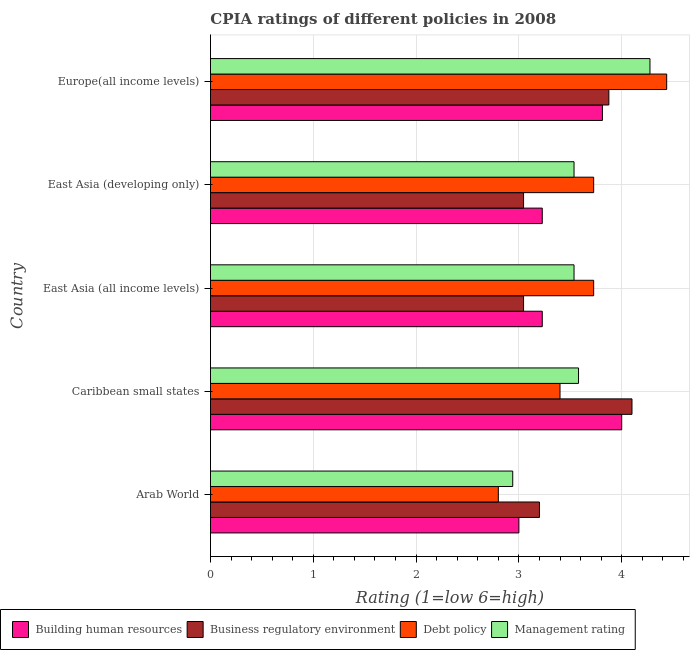Are the number of bars on each tick of the Y-axis equal?
Make the answer very short. Yes. How many bars are there on the 2nd tick from the bottom?
Provide a short and direct response. 4. What is the label of the 3rd group of bars from the top?
Make the answer very short. East Asia (all income levels). What is the cpia rating of business regulatory environment in Europe(all income levels)?
Provide a succinct answer. 3.88. In which country was the cpia rating of debt policy maximum?
Ensure brevity in your answer.  Europe(all income levels). In which country was the cpia rating of management minimum?
Keep it short and to the point. Arab World. What is the total cpia rating of business regulatory environment in the graph?
Your answer should be compact. 17.27. What is the difference between the cpia rating of business regulatory environment in East Asia (developing only) and that in Europe(all income levels)?
Offer a terse response. -0.83. What is the difference between the cpia rating of building human resources in Europe(all income levels) and the cpia rating of management in East Asia (all income levels)?
Make the answer very short. 0.28. What is the average cpia rating of debt policy per country?
Provide a succinct answer. 3.62. What is the ratio of the cpia rating of business regulatory environment in East Asia (developing only) to that in Europe(all income levels)?
Offer a terse response. 0.79. What is the difference between the highest and the second highest cpia rating of building human resources?
Ensure brevity in your answer.  0.19. What is the difference between the highest and the lowest cpia rating of debt policy?
Your response must be concise. 1.64. Is the sum of the cpia rating of management in Caribbean small states and Europe(all income levels) greater than the maximum cpia rating of debt policy across all countries?
Offer a very short reply. Yes. What does the 4th bar from the top in East Asia (all income levels) represents?
Your response must be concise. Building human resources. What does the 1st bar from the bottom in Caribbean small states represents?
Your answer should be very brief. Building human resources. What is the difference between two consecutive major ticks on the X-axis?
Provide a short and direct response. 1. Are the values on the major ticks of X-axis written in scientific E-notation?
Ensure brevity in your answer.  No. Does the graph contain any zero values?
Make the answer very short. No. How many legend labels are there?
Ensure brevity in your answer.  4. How are the legend labels stacked?
Provide a short and direct response. Horizontal. What is the title of the graph?
Provide a short and direct response. CPIA ratings of different policies in 2008. Does "Japan" appear as one of the legend labels in the graph?
Provide a succinct answer. No. What is the label or title of the X-axis?
Offer a very short reply. Rating (1=low 6=high). What is the Rating (1=low 6=high) of Building human resources in Arab World?
Your response must be concise. 3. What is the Rating (1=low 6=high) in Business regulatory environment in Arab World?
Offer a very short reply. 3.2. What is the Rating (1=low 6=high) in Management rating in Arab World?
Your answer should be compact. 2.94. What is the Rating (1=low 6=high) of Business regulatory environment in Caribbean small states?
Make the answer very short. 4.1. What is the Rating (1=low 6=high) of Management rating in Caribbean small states?
Give a very brief answer. 3.58. What is the Rating (1=low 6=high) in Building human resources in East Asia (all income levels)?
Your response must be concise. 3.23. What is the Rating (1=low 6=high) in Business regulatory environment in East Asia (all income levels)?
Offer a very short reply. 3.05. What is the Rating (1=low 6=high) of Debt policy in East Asia (all income levels)?
Ensure brevity in your answer.  3.73. What is the Rating (1=low 6=high) of Management rating in East Asia (all income levels)?
Your answer should be very brief. 3.54. What is the Rating (1=low 6=high) of Building human resources in East Asia (developing only)?
Your answer should be very brief. 3.23. What is the Rating (1=low 6=high) of Business regulatory environment in East Asia (developing only)?
Give a very brief answer. 3.05. What is the Rating (1=low 6=high) in Debt policy in East Asia (developing only)?
Ensure brevity in your answer.  3.73. What is the Rating (1=low 6=high) in Management rating in East Asia (developing only)?
Your response must be concise. 3.54. What is the Rating (1=low 6=high) of Building human resources in Europe(all income levels)?
Provide a succinct answer. 3.81. What is the Rating (1=low 6=high) of Business regulatory environment in Europe(all income levels)?
Offer a very short reply. 3.88. What is the Rating (1=low 6=high) in Debt policy in Europe(all income levels)?
Provide a short and direct response. 4.44. What is the Rating (1=low 6=high) in Management rating in Europe(all income levels)?
Ensure brevity in your answer.  4.28. Across all countries, what is the maximum Rating (1=low 6=high) in Debt policy?
Make the answer very short. 4.44. Across all countries, what is the maximum Rating (1=low 6=high) of Management rating?
Offer a terse response. 4.28. Across all countries, what is the minimum Rating (1=low 6=high) in Business regulatory environment?
Ensure brevity in your answer.  3.05. Across all countries, what is the minimum Rating (1=low 6=high) in Management rating?
Offer a terse response. 2.94. What is the total Rating (1=low 6=high) of Building human resources in the graph?
Your response must be concise. 17.27. What is the total Rating (1=low 6=high) of Business regulatory environment in the graph?
Your answer should be very brief. 17.27. What is the total Rating (1=low 6=high) in Debt policy in the graph?
Provide a short and direct response. 18.09. What is the total Rating (1=low 6=high) of Management rating in the graph?
Provide a short and direct response. 17.87. What is the difference between the Rating (1=low 6=high) in Business regulatory environment in Arab World and that in Caribbean small states?
Your answer should be very brief. -0.9. What is the difference between the Rating (1=low 6=high) in Debt policy in Arab World and that in Caribbean small states?
Your answer should be very brief. -0.6. What is the difference between the Rating (1=low 6=high) in Management rating in Arab World and that in Caribbean small states?
Your response must be concise. -0.64. What is the difference between the Rating (1=low 6=high) of Building human resources in Arab World and that in East Asia (all income levels)?
Your response must be concise. -0.23. What is the difference between the Rating (1=low 6=high) in Business regulatory environment in Arab World and that in East Asia (all income levels)?
Offer a terse response. 0.15. What is the difference between the Rating (1=low 6=high) of Debt policy in Arab World and that in East Asia (all income levels)?
Give a very brief answer. -0.93. What is the difference between the Rating (1=low 6=high) in Management rating in Arab World and that in East Asia (all income levels)?
Offer a very short reply. -0.6. What is the difference between the Rating (1=low 6=high) in Building human resources in Arab World and that in East Asia (developing only)?
Your response must be concise. -0.23. What is the difference between the Rating (1=low 6=high) of Business regulatory environment in Arab World and that in East Asia (developing only)?
Your answer should be very brief. 0.15. What is the difference between the Rating (1=low 6=high) in Debt policy in Arab World and that in East Asia (developing only)?
Offer a terse response. -0.93. What is the difference between the Rating (1=low 6=high) in Management rating in Arab World and that in East Asia (developing only)?
Offer a very short reply. -0.6. What is the difference between the Rating (1=low 6=high) in Building human resources in Arab World and that in Europe(all income levels)?
Keep it short and to the point. -0.81. What is the difference between the Rating (1=low 6=high) of Business regulatory environment in Arab World and that in Europe(all income levels)?
Provide a short and direct response. -0.68. What is the difference between the Rating (1=low 6=high) of Debt policy in Arab World and that in Europe(all income levels)?
Offer a very short reply. -1.64. What is the difference between the Rating (1=low 6=high) in Management rating in Arab World and that in Europe(all income levels)?
Provide a succinct answer. -1.33. What is the difference between the Rating (1=low 6=high) in Building human resources in Caribbean small states and that in East Asia (all income levels)?
Provide a succinct answer. 0.77. What is the difference between the Rating (1=low 6=high) in Business regulatory environment in Caribbean small states and that in East Asia (all income levels)?
Provide a succinct answer. 1.05. What is the difference between the Rating (1=low 6=high) of Debt policy in Caribbean small states and that in East Asia (all income levels)?
Keep it short and to the point. -0.33. What is the difference between the Rating (1=low 6=high) of Management rating in Caribbean small states and that in East Asia (all income levels)?
Your answer should be compact. 0.04. What is the difference between the Rating (1=low 6=high) in Building human resources in Caribbean small states and that in East Asia (developing only)?
Your answer should be very brief. 0.77. What is the difference between the Rating (1=low 6=high) in Business regulatory environment in Caribbean small states and that in East Asia (developing only)?
Offer a terse response. 1.05. What is the difference between the Rating (1=low 6=high) of Debt policy in Caribbean small states and that in East Asia (developing only)?
Offer a terse response. -0.33. What is the difference between the Rating (1=low 6=high) in Management rating in Caribbean small states and that in East Asia (developing only)?
Your answer should be compact. 0.04. What is the difference between the Rating (1=low 6=high) in Building human resources in Caribbean small states and that in Europe(all income levels)?
Offer a very short reply. 0.19. What is the difference between the Rating (1=low 6=high) in Business regulatory environment in Caribbean small states and that in Europe(all income levels)?
Provide a short and direct response. 0.23. What is the difference between the Rating (1=low 6=high) in Debt policy in Caribbean small states and that in Europe(all income levels)?
Provide a succinct answer. -1.04. What is the difference between the Rating (1=low 6=high) of Management rating in Caribbean small states and that in Europe(all income levels)?
Ensure brevity in your answer.  -0.69. What is the difference between the Rating (1=low 6=high) in Building human resources in East Asia (all income levels) and that in East Asia (developing only)?
Provide a short and direct response. 0. What is the difference between the Rating (1=low 6=high) of Building human resources in East Asia (all income levels) and that in Europe(all income levels)?
Keep it short and to the point. -0.59. What is the difference between the Rating (1=low 6=high) of Business regulatory environment in East Asia (all income levels) and that in Europe(all income levels)?
Keep it short and to the point. -0.83. What is the difference between the Rating (1=low 6=high) in Debt policy in East Asia (all income levels) and that in Europe(all income levels)?
Ensure brevity in your answer.  -0.71. What is the difference between the Rating (1=low 6=high) in Management rating in East Asia (all income levels) and that in Europe(all income levels)?
Your answer should be compact. -0.74. What is the difference between the Rating (1=low 6=high) of Building human resources in East Asia (developing only) and that in Europe(all income levels)?
Offer a terse response. -0.59. What is the difference between the Rating (1=low 6=high) in Business regulatory environment in East Asia (developing only) and that in Europe(all income levels)?
Your answer should be compact. -0.83. What is the difference between the Rating (1=low 6=high) in Debt policy in East Asia (developing only) and that in Europe(all income levels)?
Provide a short and direct response. -0.71. What is the difference between the Rating (1=low 6=high) of Management rating in East Asia (developing only) and that in Europe(all income levels)?
Offer a terse response. -0.74. What is the difference between the Rating (1=low 6=high) of Building human resources in Arab World and the Rating (1=low 6=high) of Business regulatory environment in Caribbean small states?
Offer a terse response. -1.1. What is the difference between the Rating (1=low 6=high) of Building human resources in Arab World and the Rating (1=low 6=high) of Management rating in Caribbean small states?
Ensure brevity in your answer.  -0.58. What is the difference between the Rating (1=low 6=high) of Business regulatory environment in Arab World and the Rating (1=low 6=high) of Management rating in Caribbean small states?
Offer a very short reply. -0.38. What is the difference between the Rating (1=low 6=high) of Debt policy in Arab World and the Rating (1=low 6=high) of Management rating in Caribbean small states?
Provide a succinct answer. -0.78. What is the difference between the Rating (1=low 6=high) in Building human resources in Arab World and the Rating (1=low 6=high) in Business regulatory environment in East Asia (all income levels)?
Your response must be concise. -0.05. What is the difference between the Rating (1=low 6=high) in Building human resources in Arab World and the Rating (1=low 6=high) in Debt policy in East Asia (all income levels)?
Your answer should be very brief. -0.73. What is the difference between the Rating (1=low 6=high) of Building human resources in Arab World and the Rating (1=low 6=high) of Management rating in East Asia (all income levels)?
Offer a terse response. -0.54. What is the difference between the Rating (1=low 6=high) of Business regulatory environment in Arab World and the Rating (1=low 6=high) of Debt policy in East Asia (all income levels)?
Your response must be concise. -0.53. What is the difference between the Rating (1=low 6=high) of Business regulatory environment in Arab World and the Rating (1=low 6=high) of Management rating in East Asia (all income levels)?
Provide a short and direct response. -0.34. What is the difference between the Rating (1=low 6=high) in Debt policy in Arab World and the Rating (1=low 6=high) in Management rating in East Asia (all income levels)?
Your answer should be very brief. -0.74. What is the difference between the Rating (1=low 6=high) in Building human resources in Arab World and the Rating (1=low 6=high) in Business regulatory environment in East Asia (developing only)?
Make the answer very short. -0.05. What is the difference between the Rating (1=low 6=high) in Building human resources in Arab World and the Rating (1=low 6=high) in Debt policy in East Asia (developing only)?
Your answer should be very brief. -0.73. What is the difference between the Rating (1=low 6=high) of Building human resources in Arab World and the Rating (1=low 6=high) of Management rating in East Asia (developing only)?
Offer a very short reply. -0.54. What is the difference between the Rating (1=low 6=high) of Business regulatory environment in Arab World and the Rating (1=low 6=high) of Debt policy in East Asia (developing only)?
Provide a succinct answer. -0.53. What is the difference between the Rating (1=low 6=high) in Business regulatory environment in Arab World and the Rating (1=low 6=high) in Management rating in East Asia (developing only)?
Keep it short and to the point. -0.34. What is the difference between the Rating (1=low 6=high) in Debt policy in Arab World and the Rating (1=low 6=high) in Management rating in East Asia (developing only)?
Offer a very short reply. -0.74. What is the difference between the Rating (1=low 6=high) in Building human resources in Arab World and the Rating (1=low 6=high) in Business regulatory environment in Europe(all income levels)?
Make the answer very short. -0.88. What is the difference between the Rating (1=low 6=high) in Building human resources in Arab World and the Rating (1=low 6=high) in Debt policy in Europe(all income levels)?
Offer a very short reply. -1.44. What is the difference between the Rating (1=low 6=high) in Building human resources in Arab World and the Rating (1=low 6=high) in Management rating in Europe(all income levels)?
Offer a terse response. -1.27. What is the difference between the Rating (1=low 6=high) of Business regulatory environment in Arab World and the Rating (1=low 6=high) of Debt policy in Europe(all income levels)?
Your answer should be very brief. -1.24. What is the difference between the Rating (1=low 6=high) in Business regulatory environment in Arab World and the Rating (1=low 6=high) in Management rating in Europe(all income levels)?
Your answer should be compact. -1.07. What is the difference between the Rating (1=low 6=high) in Debt policy in Arab World and the Rating (1=low 6=high) in Management rating in Europe(all income levels)?
Your answer should be very brief. -1.48. What is the difference between the Rating (1=low 6=high) of Building human resources in Caribbean small states and the Rating (1=low 6=high) of Business regulatory environment in East Asia (all income levels)?
Offer a terse response. 0.95. What is the difference between the Rating (1=low 6=high) in Building human resources in Caribbean small states and the Rating (1=low 6=high) in Debt policy in East Asia (all income levels)?
Make the answer very short. 0.27. What is the difference between the Rating (1=low 6=high) of Building human resources in Caribbean small states and the Rating (1=low 6=high) of Management rating in East Asia (all income levels)?
Your response must be concise. 0.46. What is the difference between the Rating (1=low 6=high) in Business regulatory environment in Caribbean small states and the Rating (1=low 6=high) in Debt policy in East Asia (all income levels)?
Provide a succinct answer. 0.37. What is the difference between the Rating (1=low 6=high) in Business regulatory environment in Caribbean small states and the Rating (1=low 6=high) in Management rating in East Asia (all income levels)?
Make the answer very short. 0.56. What is the difference between the Rating (1=low 6=high) of Debt policy in Caribbean small states and the Rating (1=low 6=high) of Management rating in East Asia (all income levels)?
Offer a terse response. -0.14. What is the difference between the Rating (1=low 6=high) in Building human resources in Caribbean small states and the Rating (1=low 6=high) in Business regulatory environment in East Asia (developing only)?
Your response must be concise. 0.95. What is the difference between the Rating (1=low 6=high) in Building human resources in Caribbean small states and the Rating (1=low 6=high) in Debt policy in East Asia (developing only)?
Your response must be concise. 0.27. What is the difference between the Rating (1=low 6=high) of Building human resources in Caribbean small states and the Rating (1=low 6=high) of Management rating in East Asia (developing only)?
Keep it short and to the point. 0.46. What is the difference between the Rating (1=low 6=high) of Business regulatory environment in Caribbean small states and the Rating (1=low 6=high) of Debt policy in East Asia (developing only)?
Make the answer very short. 0.37. What is the difference between the Rating (1=low 6=high) of Business regulatory environment in Caribbean small states and the Rating (1=low 6=high) of Management rating in East Asia (developing only)?
Provide a succinct answer. 0.56. What is the difference between the Rating (1=low 6=high) of Debt policy in Caribbean small states and the Rating (1=low 6=high) of Management rating in East Asia (developing only)?
Your answer should be compact. -0.14. What is the difference between the Rating (1=low 6=high) of Building human resources in Caribbean small states and the Rating (1=low 6=high) of Debt policy in Europe(all income levels)?
Keep it short and to the point. -0.44. What is the difference between the Rating (1=low 6=high) in Building human resources in Caribbean small states and the Rating (1=low 6=high) in Management rating in Europe(all income levels)?
Make the answer very short. -0.28. What is the difference between the Rating (1=low 6=high) of Business regulatory environment in Caribbean small states and the Rating (1=low 6=high) of Debt policy in Europe(all income levels)?
Offer a terse response. -0.34. What is the difference between the Rating (1=low 6=high) of Business regulatory environment in Caribbean small states and the Rating (1=low 6=high) of Management rating in Europe(all income levels)?
Offer a very short reply. -0.17. What is the difference between the Rating (1=low 6=high) in Debt policy in Caribbean small states and the Rating (1=low 6=high) in Management rating in Europe(all income levels)?
Offer a terse response. -0.88. What is the difference between the Rating (1=low 6=high) of Building human resources in East Asia (all income levels) and the Rating (1=low 6=high) of Business regulatory environment in East Asia (developing only)?
Offer a very short reply. 0.18. What is the difference between the Rating (1=low 6=high) in Building human resources in East Asia (all income levels) and the Rating (1=low 6=high) in Debt policy in East Asia (developing only)?
Provide a succinct answer. -0.5. What is the difference between the Rating (1=low 6=high) of Building human resources in East Asia (all income levels) and the Rating (1=low 6=high) of Management rating in East Asia (developing only)?
Give a very brief answer. -0.31. What is the difference between the Rating (1=low 6=high) of Business regulatory environment in East Asia (all income levels) and the Rating (1=low 6=high) of Debt policy in East Asia (developing only)?
Make the answer very short. -0.68. What is the difference between the Rating (1=low 6=high) of Business regulatory environment in East Asia (all income levels) and the Rating (1=low 6=high) of Management rating in East Asia (developing only)?
Offer a very short reply. -0.49. What is the difference between the Rating (1=low 6=high) of Debt policy in East Asia (all income levels) and the Rating (1=low 6=high) of Management rating in East Asia (developing only)?
Your answer should be compact. 0.19. What is the difference between the Rating (1=low 6=high) in Building human resources in East Asia (all income levels) and the Rating (1=low 6=high) in Business regulatory environment in Europe(all income levels)?
Keep it short and to the point. -0.65. What is the difference between the Rating (1=low 6=high) in Building human resources in East Asia (all income levels) and the Rating (1=low 6=high) in Debt policy in Europe(all income levels)?
Provide a short and direct response. -1.21. What is the difference between the Rating (1=low 6=high) of Building human resources in East Asia (all income levels) and the Rating (1=low 6=high) of Management rating in Europe(all income levels)?
Your answer should be very brief. -1.05. What is the difference between the Rating (1=low 6=high) in Business regulatory environment in East Asia (all income levels) and the Rating (1=low 6=high) in Debt policy in Europe(all income levels)?
Provide a succinct answer. -1.39. What is the difference between the Rating (1=low 6=high) in Business regulatory environment in East Asia (all income levels) and the Rating (1=low 6=high) in Management rating in Europe(all income levels)?
Offer a very short reply. -1.23. What is the difference between the Rating (1=low 6=high) of Debt policy in East Asia (all income levels) and the Rating (1=low 6=high) of Management rating in Europe(all income levels)?
Provide a short and direct response. -0.55. What is the difference between the Rating (1=low 6=high) in Building human resources in East Asia (developing only) and the Rating (1=low 6=high) in Business regulatory environment in Europe(all income levels)?
Keep it short and to the point. -0.65. What is the difference between the Rating (1=low 6=high) of Building human resources in East Asia (developing only) and the Rating (1=low 6=high) of Debt policy in Europe(all income levels)?
Provide a short and direct response. -1.21. What is the difference between the Rating (1=low 6=high) of Building human resources in East Asia (developing only) and the Rating (1=low 6=high) of Management rating in Europe(all income levels)?
Offer a terse response. -1.05. What is the difference between the Rating (1=low 6=high) of Business regulatory environment in East Asia (developing only) and the Rating (1=low 6=high) of Debt policy in Europe(all income levels)?
Provide a succinct answer. -1.39. What is the difference between the Rating (1=low 6=high) of Business regulatory environment in East Asia (developing only) and the Rating (1=low 6=high) of Management rating in Europe(all income levels)?
Provide a short and direct response. -1.23. What is the difference between the Rating (1=low 6=high) of Debt policy in East Asia (developing only) and the Rating (1=low 6=high) of Management rating in Europe(all income levels)?
Make the answer very short. -0.55. What is the average Rating (1=low 6=high) in Building human resources per country?
Provide a succinct answer. 3.45. What is the average Rating (1=low 6=high) of Business regulatory environment per country?
Give a very brief answer. 3.45. What is the average Rating (1=low 6=high) of Debt policy per country?
Provide a succinct answer. 3.62. What is the average Rating (1=low 6=high) of Management rating per country?
Ensure brevity in your answer.  3.57. What is the difference between the Rating (1=low 6=high) in Building human resources and Rating (1=low 6=high) in Management rating in Arab World?
Offer a terse response. 0.06. What is the difference between the Rating (1=low 6=high) of Business regulatory environment and Rating (1=low 6=high) of Debt policy in Arab World?
Offer a very short reply. 0.4. What is the difference between the Rating (1=low 6=high) in Business regulatory environment and Rating (1=low 6=high) in Management rating in Arab World?
Make the answer very short. 0.26. What is the difference between the Rating (1=low 6=high) in Debt policy and Rating (1=low 6=high) in Management rating in Arab World?
Your answer should be compact. -0.14. What is the difference between the Rating (1=low 6=high) in Building human resources and Rating (1=low 6=high) in Business regulatory environment in Caribbean small states?
Your answer should be very brief. -0.1. What is the difference between the Rating (1=low 6=high) in Building human resources and Rating (1=low 6=high) in Management rating in Caribbean small states?
Offer a very short reply. 0.42. What is the difference between the Rating (1=low 6=high) in Business regulatory environment and Rating (1=low 6=high) in Management rating in Caribbean small states?
Your response must be concise. 0.52. What is the difference between the Rating (1=low 6=high) of Debt policy and Rating (1=low 6=high) of Management rating in Caribbean small states?
Ensure brevity in your answer.  -0.18. What is the difference between the Rating (1=low 6=high) of Building human resources and Rating (1=low 6=high) of Business regulatory environment in East Asia (all income levels)?
Make the answer very short. 0.18. What is the difference between the Rating (1=low 6=high) in Building human resources and Rating (1=low 6=high) in Management rating in East Asia (all income levels)?
Your answer should be very brief. -0.31. What is the difference between the Rating (1=low 6=high) in Business regulatory environment and Rating (1=low 6=high) in Debt policy in East Asia (all income levels)?
Offer a very short reply. -0.68. What is the difference between the Rating (1=low 6=high) of Business regulatory environment and Rating (1=low 6=high) of Management rating in East Asia (all income levels)?
Keep it short and to the point. -0.49. What is the difference between the Rating (1=low 6=high) of Debt policy and Rating (1=low 6=high) of Management rating in East Asia (all income levels)?
Keep it short and to the point. 0.19. What is the difference between the Rating (1=low 6=high) in Building human resources and Rating (1=low 6=high) in Business regulatory environment in East Asia (developing only)?
Offer a very short reply. 0.18. What is the difference between the Rating (1=low 6=high) of Building human resources and Rating (1=low 6=high) of Management rating in East Asia (developing only)?
Your answer should be very brief. -0.31. What is the difference between the Rating (1=low 6=high) of Business regulatory environment and Rating (1=low 6=high) of Debt policy in East Asia (developing only)?
Provide a short and direct response. -0.68. What is the difference between the Rating (1=low 6=high) of Business regulatory environment and Rating (1=low 6=high) of Management rating in East Asia (developing only)?
Your response must be concise. -0.49. What is the difference between the Rating (1=low 6=high) in Debt policy and Rating (1=low 6=high) in Management rating in East Asia (developing only)?
Provide a succinct answer. 0.19. What is the difference between the Rating (1=low 6=high) in Building human resources and Rating (1=low 6=high) in Business regulatory environment in Europe(all income levels)?
Keep it short and to the point. -0.06. What is the difference between the Rating (1=low 6=high) of Building human resources and Rating (1=low 6=high) of Debt policy in Europe(all income levels)?
Give a very brief answer. -0.62. What is the difference between the Rating (1=low 6=high) in Building human resources and Rating (1=low 6=high) in Management rating in Europe(all income levels)?
Your response must be concise. -0.46. What is the difference between the Rating (1=low 6=high) of Business regulatory environment and Rating (1=low 6=high) of Debt policy in Europe(all income levels)?
Your response must be concise. -0.56. What is the difference between the Rating (1=low 6=high) in Business regulatory environment and Rating (1=low 6=high) in Management rating in Europe(all income levels)?
Keep it short and to the point. -0.4. What is the difference between the Rating (1=low 6=high) in Debt policy and Rating (1=low 6=high) in Management rating in Europe(all income levels)?
Your answer should be compact. 0.16. What is the ratio of the Rating (1=low 6=high) of Business regulatory environment in Arab World to that in Caribbean small states?
Give a very brief answer. 0.78. What is the ratio of the Rating (1=low 6=high) of Debt policy in Arab World to that in Caribbean small states?
Provide a succinct answer. 0.82. What is the ratio of the Rating (1=low 6=high) of Management rating in Arab World to that in Caribbean small states?
Your answer should be compact. 0.82. What is the ratio of the Rating (1=low 6=high) of Building human resources in Arab World to that in East Asia (all income levels)?
Offer a very short reply. 0.93. What is the ratio of the Rating (1=low 6=high) in Business regulatory environment in Arab World to that in East Asia (all income levels)?
Your answer should be compact. 1.05. What is the ratio of the Rating (1=low 6=high) in Debt policy in Arab World to that in East Asia (all income levels)?
Offer a terse response. 0.75. What is the ratio of the Rating (1=low 6=high) of Management rating in Arab World to that in East Asia (all income levels)?
Keep it short and to the point. 0.83. What is the ratio of the Rating (1=low 6=high) of Building human resources in Arab World to that in East Asia (developing only)?
Your answer should be very brief. 0.93. What is the ratio of the Rating (1=low 6=high) in Business regulatory environment in Arab World to that in East Asia (developing only)?
Offer a very short reply. 1.05. What is the ratio of the Rating (1=low 6=high) in Debt policy in Arab World to that in East Asia (developing only)?
Ensure brevity in your answer.  0.75. What is the ratio of the Rating (1=low 6=high) in Management rating in Arab World to that in East Asia (developing only)?
Your response must be concise. 0.83. What is the ratio of the Rating (1=low 6=high) of Building human resources in Arab World to that in Europe(all income levels)?
Your response must be concise. 0.79. What is the ratio of the Rating (1=low 6=high) in Business regulatory environment in Arab World to that in Europe(all income levels)?
Offer a very short reply. 0.83. What is the ratio of the Rating (1=low 6=high) in Debt policy in Arab World to that in Europe(all income levels)?
Your response must be concise. 0.63. What is the ratio of the Rating (1=low 6=high) in Management rating in Arab World to that in Europe(all income levels)?
Provide a succinct answer. 0.69. What is the ratio of the Rating (1=low 6=high) of Building human resources in Caribbean small states to that in East Asia (all income levels)?
Your response must be concise. 1.24. What is the ratio of the Rating (1=low 6=high) in Business regulatory environment in Caribbean small states to that in East Asia (all income levels)?
Keep it short and to the point. 1.35. What is the ratio of the Rating (1=low 6=high) of Debt policy in Caribbean small states to that in East Asia (all income levels)?
Give a very brief answer. 0.91. What is the ratio of the Rating (1=low 6=high) in Management rating in Caribbean small states to that in East Asia (all income levels)?
Your answer should be very brief. 1.01. What is the ratio of the Rating (1=low 6=high) of Building human resources in Caribbean small states to that in East Asia (developing only)?
Your response must be concise. 1.24. What is the ratio of the Rating (1=low 6=high) in Business regulatory environment in Caribbean small states to that in East Asia (developing only)?
Offer a very short reply. 1.35. What is the ratio of the Rating (1=low 6=high) in Debt policy in Caribbean small states to that in East Asia (developing only)?
Your answer should be very brief. 0.91. What is the ratio of the Rating (1=low 6=high) in Management rating in Caribbean small states to that in East Asia (developing only)?
Your response must be concise. 1.01. What is the ratio of the Rating (1=low 6=high) in Building human resources in Caribbean small states to that in Europe(all income levels)?
Your answer should be compact. 1.05. What is the ratio of the Rating (1=low 6=high) in Business regulatory environment in Caribbean small states to that in Europe(all income levels)?
Provide a short and direct response. 1.06. What is the ratio of the Rating (1=low 6=high) of Debt policy in Caribbean small states to that in Europe(all income levels)?
Offer a very short reply. 0.77. What is the ratio of the Rating (1=low 6=high) in Management rating in Caribbean small states to that in Europe(all income levels)?
Ensure brevity in your answer.  0.84. What is the ratio of the Rating (1=low 6=high) in Building human resources in East Asia (all income levels) to that in East Asia (developing only)?
Provide a short and direct response. 1. What is the ratio of the Rating (1=low 6=high) of Building human resources in East Asia (all income levels) to that in Europe(all income levels)?
Offer a very short reply. 0.85. What is the ratio of the Rating (1=low 6=high) of Business regulatory environment in East Asia (all income levels) to that in Europe(all income levels)?
Your response must be concise. 0.79. What is the ratio of the Rating (1=low 6=high) in Debt policy in East Asia (all income levels) to that in Europe(all income levels)?
Make the answer very short. 0.84. What is the ratio of the Rating (1=low 6=high) in Management rating in East Asia (all income levels) to that in Europe(all income levels)?
Offer a very short reply. 0.83. What is the ratio of the Rating (1=low 6=high) in Building human resources in East Asia (developing only) to that in Europe(all income levels)?
Provide a succinct answer. 0.85. What is the ratio of the Rating (1=low 6=high) of Business regulatory environment in East Asia (developing only) to that in Europe(all income levels)?
Your answer should be compact. 0.79. What is the ratio of the Rating (1=low 6=high) in Debt policy in East Asia (developing only) to that in Europe(all income levels)?
Your answer should be very brief. 0.84. What is the ratio of the Rating (1=low 6=high) in Management rating in East Asia (developing only) to that in Europe(all income levels)?
Your answer should be compact. 0.83. What is the difference between the highest and the second highest Rating (1=low 6=high) of Building human resources?
Offer a very short reply. 0.19. What is the difference between the highest and the second highest Rating (1=low 6=high) of Business regulatory environment?
Your response must be concise. 0.23. What is the difference between the highest and the second highest Rating (1=low 6=high) of Debt policy?
Keep it short and to the point. 0.71. What is the difference between the highest and the second highest Rating (1=low 6=high) of Management rating?
Keep it short and to the point. 0.69. What is the difference between the highest and the lowest Rating (1=low 6=high) of Business regulatory environment?
Your answer should be very brief. 1.05. What is the difference between the highest and the lowest Rating (1=low 6=high) of Debt policy?
Make the answer very short. 1.64. What is the difference between the highest and the lowest Rating (1=low 6=high) of Management rating?
Offer a terse response. 1.33. 